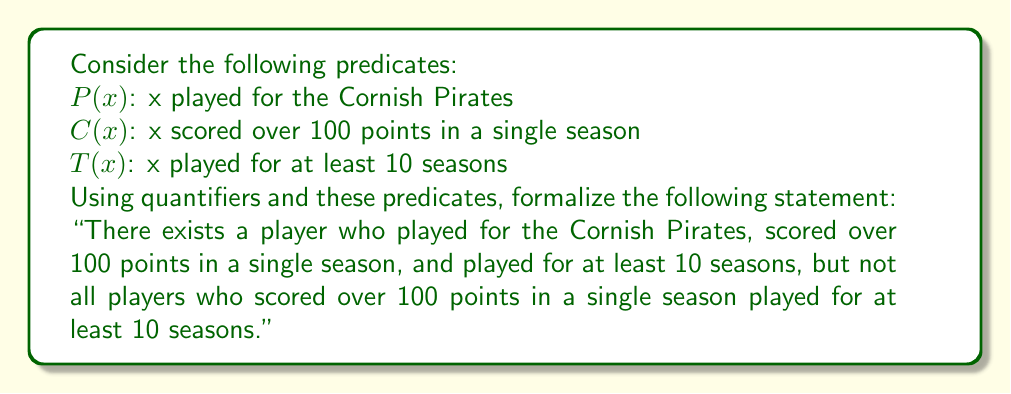Can you answer this question? To formalize this statement, we need to break it down into two parts and use the appropriate quantifiers and logical connectives:

1. "There exists a player who played for the Cornish Pirates, scored over 100 points in a single season, and played for at least 10 seasons":
   This can be expressed as: $\exists x (P(x) \land C(x) \land T(x))$

2. "Not all players who scored over 100 points in a single season played for at least 10 seasons":
   This can be expressed as: $\neg \forall x (C(x) \rightarrow T(x))$

To combine these two parts, we use the logical conjunction (AND) operator:

$$[\exists x (P(x) \land C(x) \land T(x))] \land [\neg \forall x (C(x) \rightarrow T(x))]$$

This formalization captures both parts of the statement:
- The existence of at least one player satisfying all three conditions
- The fact that not all high-scoring players had long careers

The use of quantifiers ($\exists$ and $\forall$) allows us to make statements about the entire set of players in the team's history, while the predicates ($P(x)$, $C(x)$, and $T(x)$) enable us to specify individual achievements.
Answer: $$[\exists x (P(x) \land C(x) \land T(x))] \land [\neg \forall x (C(x) \rightarrow T(x))]$$ 